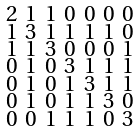<formula> <loc_0><loc_0><loc_500><loc_500>\begin{smallmatrix} 2 & 1 & 1 & 0 & 0 & 0 & 0 \\ 1 & 3 & 1 & 1 & 1 & 1 & 0 \\ 1 & 1 & 3 & 0 & 0 & 0 & 1 \\ 0 & 1 & 0 & 3 & 1 & 1 & 1 \\ 0 & 1 & 0 & 1 & 3 & 1 & 1 \\ 0 & 1 & 0 & 1 & 1 & 3 & 0 \\ 0 & 0 & 1 & 1 & 1 & 0 & 3 \end{smallmatrix}</formula> 